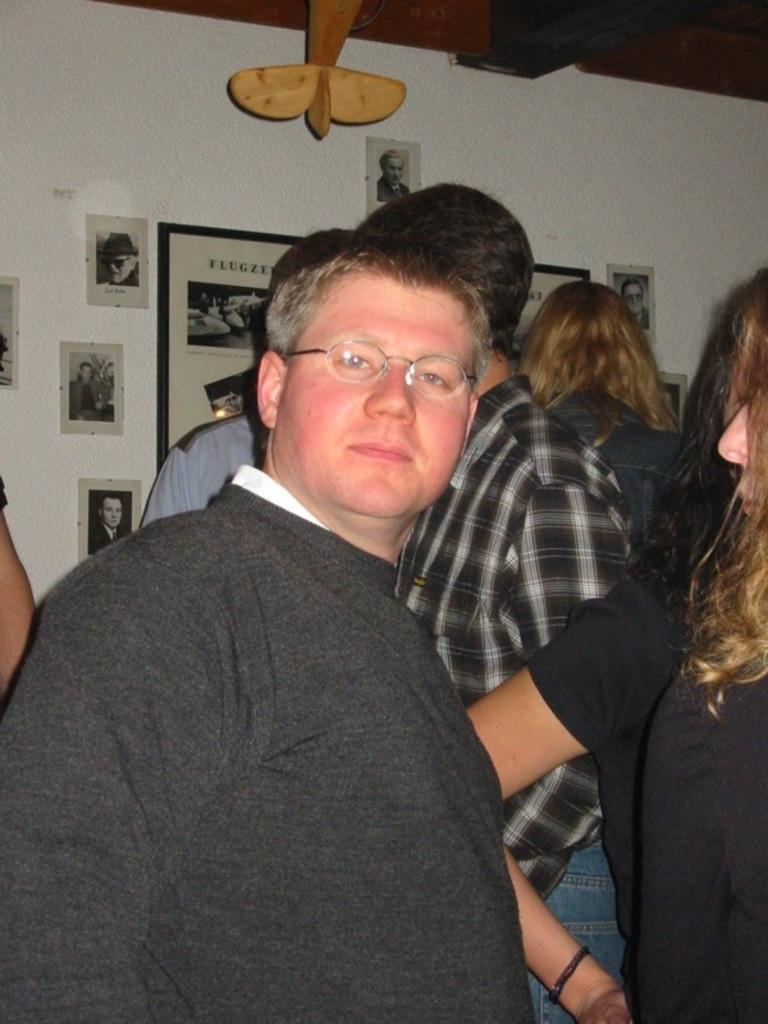What is the main subject in the front of the image? There is a man standing in the front of the image. What can be seen in the center of the image? There are persons in the center of the image. What is visible on the wall in the background of the image? There are posters on the wall in the background of the image. What features do the posters have? The posters have text and images on them. What type of plantation is visible in the image? There is no plantation present in the image. What position does the man hold in the image? The provided facts do not mention any specific position or role for the man in the image. 